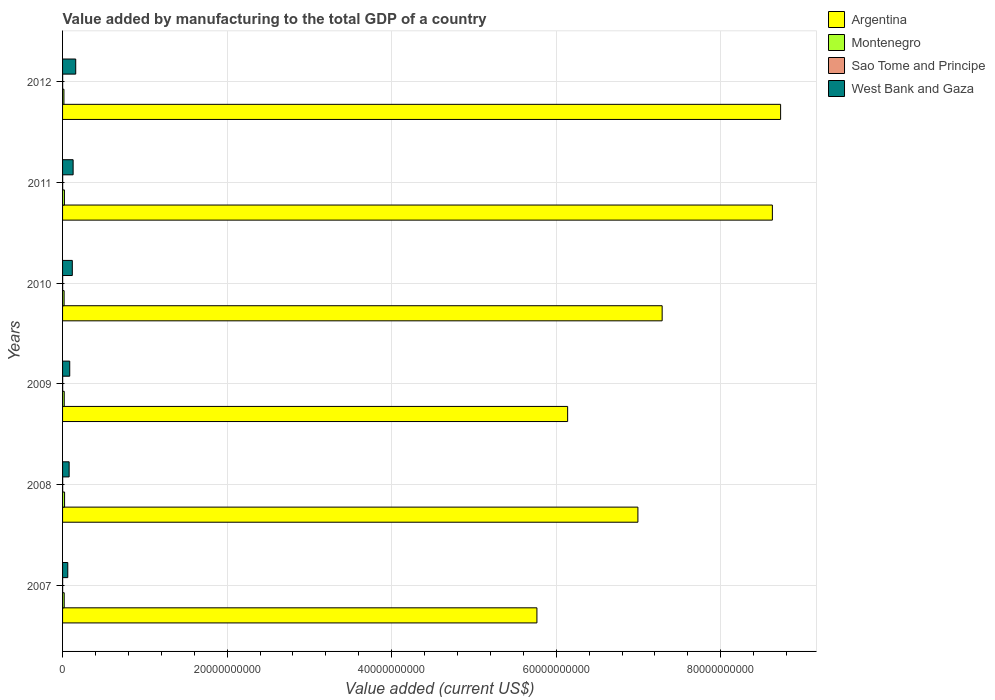Are the number of bars per tick equal to the number of legend labels?
Make the answer very short. Yes. How many bars are there on the 2nd tick from the top?
Provide a succinct answer. 4. How many bars are there on the 1st tick from the bottom?
Provide a short and direct response. 4. What is the label of the 3rd group of bars from the top?
Give a very brief answer. 2010. In how many cases, is the number of bars for a given year not equal to the number of legend labels?
Your response must be concise. 0. What is the value added by manufacturing to the total GDP in Montenegro in 2011?
Ensure brevity in your answer.  2.26e+08. Across all years, what is the maximum value added by manufacturing to the total GDP in Sao Tome and Principe?
Ensure brevity in your answer.  1.17e+07. Across all years, what is the minimum value added by manufacturing to the total GDP in West Bank and Gaza?
Give a very brief answer. 6.35e+08. What is the total value added by manufacturing to the total GDP in Sao Tome and Principe in the graph?
Ensure brevity in your answer.  6.28e+07. What is the difference between the value added by manufacturing to the total GDP in Sao Tome and Principe in 2008 and that in 2011?
Your response must be concise. 1.11e+04. What is the difference between the value added by manufacturing to the total GDP in Sao Tome and Principe in 2007 and the value added by manufacturing to the total GDP in Montenegro in 2012?
Provide a short and direct response. -1.60e+08. What is the average value added by manufacturing to the total GDP in Sao Tome and Principe per year?
Make the answer very short. 1.05e+07. In the year 2011, what is the difference between the value added by manufacturing to the total GDP in Argentina and value added by manufacturing to the total GDP in West Bank and Gaza?
Make the answer very short. 8.50e+1. What is the ratio of the value added by manufacturing to the total GDP in Argentina in 2007 to that in 2012?
Provide a succinct answer. 0.66. Is the value added by manufacturing to the total GDP in West Bank and Gaza in 2009 less than that in 2011?
Provide a succinct answer. Yes. Is the difference between the value added by manufacturing to the total GDP in Argentina in 2007 and 2012 greater than the difference between the value added by manufacturing to the total GDP in West Bank and Gaza in 2007 and 2012?
Offer a terse response. No. What is the difference between the highest and the second highest value added by manufacturing to the total GDP in Argentina?
Ensure brevity in your answer.  1.00e+09. What is the difference between the highest and the lowest value added by manufacturing to the total GDP in Sao Tome and Principe?
Provide a succinct answer. 4.55e+06. Is the sum of the value added by manufacturing to the total GDP in Argentina in 2008 and 2010 greater than the maximum value added by manufacturing to the total GDP in West Bank and Gaza across all years?
Your answer should be compact. Yes. Is it the case that in every year, the sum of the value added by manufacturing to the total GDP in Montenegro and value added by manufacturing to the total GDP in West Bank and Gaza is greater than the sum of value added by manufacturing to the total GDP in Sao Tome and Principe and value added by manufacturing to the total GDP in Argentina?
Ensure brevity in your answer.  No. What does the 4th bar from the bottom in 2012 represents?
Ensure brevity in your answer.  West Bank and Gaza. Is it the case that in every year, the sum of the value added by manufacturing to the total GDP in Montenegro and value added by manufacturing to the total GDP in Sao Tome and Principe is greater than the value added by manufacturing to the total GDP in Argentina?
Make the answer very short. No. Are all the bars in the graph horizontal?
Your answer should be compact. Yes. How many years are there in the graph?
Provide a short and direct response. 6. What is the difference between two consecutive major ticks on the X-axis?
Your answer should be compact. 2.00e+1. Does the graph contain any zero values?
Give a very brief answer. No. Where does the legend appear in the graph?
Offer a terse response. Top right. How many legend labels are there?
Your answer should be compact. 4. What is the title of the graph?
Your response must be concise. Value added by manufacturing to the total GDP of a country. What is the label or title of the X-axis?
Your answer should be very brief. Value added (current US$). What is the Value added (current US$) in Argentina in 2007?
Your answer should be compact. 5.77e+1. What is the Value added (current US$) in Montenegro in 2007?
Provide a succinct answer. 1.98e+08. What is the Value added (current US$) of Sao Tome and Principe in 2007?
Your answer should be very brief. 7.11e+06. What is the Value added (current US$) in West Bank and Gaza in 2007?
Your answer should be very brief. 6.35e+08. What is the Value added (current US$) in Argentina in 2008?
Ensure brevity in your answer.  6.99e+1. What is the Value added (current US$) of Montenegro in 2008?
Provide a succinct answer. 2.44e+08. What is the Value added (current US$) in Sao Tome and Principe in 2008?
Provide a short and direct response. 1.15e+07. What is the Value added (current US$) of West Bank and Gaza in 2008?
Your answer should be very brief. 7.98e+08. What is the Value added (current US$) in Argentina in 2009?
Your answer should be very brief. 6.14e+1. What is the Value added (current US$) of Montenegro in 2009?
Provide a succinct answer. 2.03e+08. What is the Value added (current US$) in Sao Tome and Principe in 2009?
Keep it short and to the point. 1.13e+07. What is the Value added (current US$) of West Bank and Gaza in 2009?
Make the answer very short. 8.71e+08. What is the Value added (current US$) in Argentina in 2010?
Provide a succinct answer. 7.29e+1. What is the Value added (current US$) of Montenegro in 2010?
Your answer should be very brief. 1.88e+08. What is the Value added (current US$) in Sao Tome and Principe in 2010?
Your response must be concise. 9.89e+06. What is the Value added (current US$) of West Bank and Gaza in 2010?
Provide a short and direct response. 1.18e+09. What is the Value added (current US$) in Argentina in 2011?
Offer a terse response. 8.63e+1. What is the Value added (current US$) of Montenegro in 2011?
Ensure brevity in your answer.  2.26e+08. What is the Value added (current US$) in Sao Tome and Principe in 2011?
Offer a very short reply. 1.14e+07. What is the Value added (current US$) in West Bank and Gaza in 2011?
Keep it short and to the point. 1.28e+09. What is the Value added (current US$) of Argentina in 2012?
Give a very brief answer. 8.73e+1. What is the Value added (current US$) of Montenegro in 2012?
Ensure brevity in your answer.  1.67e+08. What is the Value added (current US$) in Sao Tome and Principe in 2012?
Provide a succinct answer. 1.17e+07. What is the Value added (current US$) in West Bank and Gaza in 2012?
Keep it short and to the point. 1.60e+09. Across all years, what is the maximum Value added (current US$) of Argentina?
Provide a succinct answer. 8.73e+1. Across all years, what is the maximum Value added (current US$) in Montenegro?
Give a very brief answer. 2.44e+08. Across all years, what is the maximum Value added (current US$) in Sao Tome and Principe?
Make the answer very short. 1.17e+07. Across all years, what is the maximum Value added (current US$) in West Bank and Gaza?
Keep it short and to the point. 1.60e+09. Across all years, what is the minimum Value added (current US$) in Argentina?
Make the answer very short. 5.77e+1. Across all years, what is the minimum Value added (current US$) of Montenegro?
Your answer should be very brief. 1.67e+08. Across all years, what is the minimum Value added (current US$) in Sao Tome and Principe?
Your answer should be very brief. 7.11e+06. Across all years, what is the minimum Value added (current US$) of West Bank and Gaza?
Ensure brevity in your answer.  6.35e+08. What is the total Value added (current US$) in Argentina in the graph?
Offer a very short reply. 4.35e+11. What is the total Value added (current US$) of Montenegro in the graph?
Provide a short and direct response. 1.23e+09. What is the total Value added (current US$) of Sao Tome and Principe in the graph?
Your answer should be very brief. 6.28e+07. What is the total Value added (current US$) of West Bank and Gaza in the graph?
Provide a short and direct response. 6.37e+09. What is the difference between the Value added (current US$) in Argentina in 2007 and that in 2008?
Keep it short and to the point. -1.23e+1. What is the difference between the Value added (current US$) in Montenegro in 2007 and that in 2008?
Make the answer very short. -4.55e+07. What is the difference between the Value added (current US$) in Sao Tome and Principe in 2007 and that in 2008?
Give a very brief answer. -4.35e+06. What is the difference between the Value added (current US$) of West Bank and Gaza in 2007 and that in 2008?
Ensure brevity in your answer.  -1.64e+08. What is the difference between the Value added (current US$) in Argentina in 2007 and that in 2009?
Offer a terse response. -3.73e+09. What is the difference between the Value added (current US$) of Montenegro in 2007 and that in 2009?
Provide a short and direct response. -4.18e+06. What is the difference between the Value added (current US$) in Sao Tome and Principe in 2007 and that in 2009?
Keep it short and to the point. -4.17e+06. What is the difference between the Value added (current US$) of West Bank and Gaza in 2007 and that in 2009?
Give a very brief answer. -2.37e+08. What is the difference between the Value added (current US$) of Argentina in 2007 and that in 2010?
Your response must be concise. -1.52e+1. What is the difference between the Value added (current US$) of Montenegro in 2007 and that in 2010?
Your answer should be very brief. 9.92e+06. What is the difference between the Value added (current US$) in Sao Tome and Principe in 2007 and that in 2010?
Provide a short and direct response. -2.78e+06. What is the difference between the Value added (current US$) of West Bank and Gaza in 2007 and that in 2010?
Your response must be concise. -5.49e+08. What is the difference between the Value added (current US$) of Argentina in 2007 and that in 2011?
Ensure brevity in your answer.  -2.86e+1. What is the difference between the Value added (current US$) of Montenegro in 2007 and that in 2011?
Provide a short and direct response. -2.73e+07. What is the difference between the Value added (current US$) in Sao Tome and Principe in 2007 and that in 2011?
Offer a terse response. -4.34e+06. What is the difference between the Value added (current US$) in West Bank and Gaza in 2007 and that in 2011?
Ensure brevity in your answer.  -6.48e+08. What is the difference between the Value added (current US$) in Argentina in 2007 and that in 2012?
Your response must be concise. -2.96e+1. What is the difference between the Value added (current US$) of Montenegro in 2007 and that in 2012?
Make the answer very short. 3.17e+07. What is the difference between the Value added (current US$) in Sao Tome and Principe in 2007 and that in 2012?
Offer a very short reply. -4.55e+06. What is the difference between the Value added (current US$) of West Bank and Gaza in 2007 and that in 2012?
Keep it short and to the point. -9.63e+08. What is the difference between the Value added (current US$) of Argentina in 2008 and that in 2009?
Keep it short and to the point. 8.54e+09. What is the difference between the Value added (current US$) in Montenegro in 2008 and that in 2009?
Provide a succinct answer. 4.13e+07. What is the difference between the Value added (current US$) of Sao Tome and Principe in 2008 and that in 2009?
Ensure brevity in your answer.  1.76e+05. What is the difference between the Value added (current US$) in West Bank and Gaza in 2008 and that in 2009?
Make the answer very short. -7.30e+07. What is the difference between the Value added (current US$) in Argentina in 2008 and that in 2010?
Offer a terse response. -2.95e+09. What is the difference between the Value added (current US$) in Montenegro in 2008 and that in 2010?
Offer a terse response. 5.54e+07. What is the difference between the Value added (current US$) of Sao Tome and Principe in 2008 and that in 2010?
Your answer should be compact. 1.56e+06. What is the difference between the Value added (current US$) in West Bank and Gaza in 2008 and that in 2010?
Your response must be concise. -3.86e+08. What is the difference between the Value added (current US$) in Argentina in 2008 and that in 2011?
Offer a terse response. -1.63e+1. What is the difference between the Value added (current US$) of Montenegro in 2008 and that in 2011?
Provide a short and direct response. 1.82e+07. What is the difference between the Value added (current US$) in Sao Tome and Principe in 2008 and that in 2011?
Offer a very short reply. 1.11e+04. What is the difference between the Value added (current US$) in West Bank and Gaza in 2008 and that in 2011?
Provide a succinct answer. -4.84e+08. What is the difference between the Value added (current US$) of Argentina in 2008 and that in 2012?
Keep it short and to the point. -1.73e+1. What is the difference between the Value added (current US$) in Montenegro in 2008 and that in 2012?
Provide a succinct answer. 7.72e+07. What is the difference between the Value added (current US$) of Sao Tome and Principe in 2008 and that in 2012?
Make the answer very short. -2.03e+05. What is the difference between the Value added (current US$) in West Bank and Gaza in 2008 and that in 2012?
Provide a short and direct response. -8.00e+08. What is the difference between the Value added (current US$) in Argentina in 2009 and that in 2010?
Offer a very short reply. -1.15e+1. What is the difference between the Value added (current US$) in Montenegro in 2009 and that in 2010?
Your answer should be compact. 1.41e+07. What is the difference between the Value added (current US$) of Sao Tome and Principe in 2009 and that in 2010?
Offer a very short reply. 1.39e+06. What is the difference between the Value added (current US$) in West Bank and Gaza in 2009 and that in 2010?
Your response must be concise. -3.13e+08. What is the difference between the Value added (current US$) of Argentina in 2009 and that in 2011?
Provide a succinct answer. -2.49e+1. What is the difference between the Value added (current US$) of Montenegro in 2009 and that in 2011?
Offer a very short reply. -2.31e+07. What is the difference between the Value added (current US$) in Sao Tome and Principe in 2009 and that in 2011?
Your response must be concise. -1.65e+05. What is the difference between the Value added (current US$) in West Bank and Gaza in 2009 and that in 2011?
Make the answer very short. -4.12e+08. What is the difference between the Value added (current US$) in Argentina in 2009 and that in 2012?
Provide a succinct answer. -2.59e+1. What is the difference between the Value added (current US$) in Montenegro in 2009 and that in 2012?
Make the answer very short. 3.59e+07. What is the difference between the Value added (current US$) of Sao Tome and Principe in 2009 and that in 2012?
Your answer should be very brief. -3.79e+05. What is the difference between the Value added (current US$) in West Bank and Gaza in 2009 and that in 2012?
Your answer should be compact. -7.27e+08. What is the difference between the Value added (current US$) of Argentina in 2010 and that in 2011?
Your answer should be very brief. -1.34e+1. What is the difference between the Value added (current US$) in Montenegro in 2010 and that in 2011?
Give a very brief answer. -3.72e+07. What is the difference between the Value added (current US$) in Sao Tome and Principe in 2010 and that in 2011?
Provide a succinct answer. -1.55e+06. What is the difference between the Value added (current US$) in West Bank and Gaza in 2010 and that in 2011?
Ensure brevity in your answer.  -9.89e+07. What is the difference between the Value added (current US$) of Argentina in 2010 and that in 2012?
Your response must be concise. -1.44e+1. What is the difference between the Value added (current US$) in Montenegro in 2010 and that in 2012?
Offer a terse response. 2.18e+07. What is the difference between the Value added (current US$) in Sao Tome and Principe in 2010 and that in 2012?
Ensure brevity in your answer.  -1.77e+06. What is the difference between the Value added (current US$) in West Bank and Gaza in 2010 and that in 2012?
Ensure brevity in your answer.  -4.14e+08. What is the difference between the Value added (current US$) in Argentina in 2011 and that in 2012?
Your answer should be compact. -1.00e+09. What is the difference between the Value added (current US$) of Montenegro in 2011 and that in 2012?
Your answer should be compact. 5.90e+07. What is the difference between the Value added (current US$) of Sao Tome and Principe in 2011 and that in 2012?
Keep it short and to the point. -2.14e+05. What is the difference between the Value added (current US$) of West Bank and Gaza in 2011 and that in 2012?
Ensure brevity in your answer.  -3.15e+08. What is the difference between the Value added (current US$) in Argentina in 2007 and the Value added (current US$) in Montenegro in 2008?
Provide a short and direct response. 5.74e+1. What is the difference between the Value added (current US$) in Argentina in 2007 and the Value added (current US$) in Sao Tome and Principe in 2008?
Provide a short and direct response. 5.76e+1. What is the difference between the Value added (current US$) of Argentina in 2007 and the Value added (current US$) of West Bank and Gaza in 2008?
Your answer should be compact. 5.69e+1. What is the difference between the Value added (current US$) of Montenegro in 2007 and the Value added (current US$) of Sao Tome and Principe in 2008?
Offer a terse response. 1.87e+08. What is the difference between the Value added (current US$) of Montenegro in 2007 and the Value added (current US$) of West Bank and Gaza in 2008?
Ensure brevity in your answer.  -6.00e+08. What is the difference between the Value added (current US$) in Sao Tome and Principe in 2007 and the Value added (current US$) in West Bank and Gaza in 2008?
Offer a terse response. -7.91e+08. What is the difference between the Value added (current US$) of Argentina in 2007 and the Value added (current US$) of Montenegro in 2009?
Keep it short and to the point. 5.75e+1. What is the difference between the Value added (current US$) of Argentina in 2007 and the Value added (current US$) of Sao Tome and Principe in 2009?
Give a very brief answer. 5.76e+1. What is the difference between the Value added (current US$) in Argentina in 2007 and the Value added (current US$) in West Bank and Gaza in 2009?
Make the answer very short. 5.68e+1. What is the difference between the Value added (current US$) in Montenegro in 2007 and the Value added (current US$) in Sao Tome and Principe in 2009?
Ensure brevity in your answer.  1.87e+08. What is the difference between the Value added (current US$) of Montenegro in 2007 and the Value added (current US$) of West Bank and Gaza in 2009?
Keep it short and to the point. -6.73e+08. What is the difference between the Value added (current US$) of Sao Tome and Principe in 2007 and the Value added (current US$) of West Bank and Gaza in 2009?
Offer a terse response. -8.64e+08. What is the difference between the Value added (current US$) of Argentina in 2007 and the Value added (current US$) of Montenegro in 2010?
Provide a succinct answer. 5.75e+1. What is the difference between the Value added (current US$) of Argentina in 2007 and the Value added (current US$) of Sao Tome and Principe in 2010?
Keep it short and to the point. 5.76e+1. What is the difference between the Value added (current US$) of Argentina in 2007 and the Value added (current US$) of West Bank and Gaza in 2010?
Ensure brevity in your answer.  5.65e+1. What is the difference between the Value added (current US$) in Montenegro in 2007 and the Value added (current US$) in Sao Tome and Principe in 2010?
Your answer should be very brief. 1.88e+08. What is the difference between the Value added (current US$) in Montenegro in 2007 and the Value added (current US$) in West Bank and Gaza in 2010?
Your answer should be very brief. -9.86e+08. What is the difference between the Value added (current US$) in Sao Tome and Principe in 2007 and the Value added (current US$) in West Bank and Gaza in 2010?
Your response must be concise. -1.18e+09. What is the difference between the Value added (current US$) of Argentina in 2007 and the Value added (current US$) of Montenegro in 2011?
Your answer should be compact. 5.74e+1. What is the difference between the Value added (current US$) of Argentina in 2007 and the Value added (current US$) of Sao Tome and Principe in 2011?
Your response must be concise. 5.76e+1. What is the difference between the Value added (current US$) of Argentina in 2007 and the Value added (current US$) of West Bank and Gaza in 2011?
Ensure brevity in your answer.  5.64e+1. What is the difference between the Value added (current US$) in Montenegro in 2007 and the Value added (current US$) in Sao Tome and Principe in 2011?
Your answer should be very brief. 1.87e+08. What is the difference between the Value added (current US$) in Montenegro in 2007 and the Value added (current US$) in West Bank and Gaza in 2011?
Your answer should be very brief. -1.08e+09. What is the difference between the Value added (current US$) in Sao Tome and Principe in 2007 and the Value added (current US$) in West Bank and Gaza in 2011?
Keep it short and to the point. -1.28e+09. What is the difference between the Value added (current US$) in Argentina in 2007 and the Value added (current US$) in Montenegro in 2012?
Provide a succinct answer. 5.75e+1. What is the difference between the Value added (current US$) in Argentina in 2007 and the Value added (current US$) in Sao Tome and Principe in 2012?
Ensure brevity in your answer.  5.76e+1. What is the difference between the Value added (current US$) in Argentina in 2007 and the Value added (current US$) in West Bank and Gaza in 2012?
Provide a succinct answer. 5.61e+1. What is the difference between the Value added (current US$) of Montenegro in 2007 and the Value added (current US$) of Sao Tome and Principe in 2012?
Your response must be concise. 1.87e+08. What is the difference between the Value added (current US$) of Montenegro in 2007 and the Value added (current US$) of West Bank and Gaza in 2012?
Your response must be concise. -1.40e+09. What is the difference between the Value added (current US$) in Sao Tome and Principe in 2007 and the Value added (current US$) in West Bank and Gaza in 2012?
Make the answer very short. -1.59e+09. What is the difference between the Value added (current US$) of Argentina in 2008 and the Value added (current US$) of Montenegro in 2009?
Ensure brevity in your answer.  6.97e+1. What is the difference between the Value added (current US$) in Argentina in 2008 and the Value added (current US$) in Sao Tome and Principe in 2009?
Your answer should be compact. 6.99e+1. What is the difference between the Value added (current US$) in Argentina in 2008 and the Value added (current US$) in West Bank and Gaza in 2009?
Offer a very short reply. 6.91e+1. What is the difference between the Value added (current US$) in Montenegro in 2008 and the Value added (current US$) in Sao Tome and Principe in 2009?
Make the answer very short. 2.33e+08. What is the difference between the Value added (current US$) in Montenegro in 2008 and the Value added (current US$) in West Bank and Gaza in 2009?
Your answer should be compact. -6.28e+08. What is the difference between the Value added (current US$) in Sao Tome and Principe in 2008 and the Value added (current US$) in West Bank and Gaza in 2009?
Keep it short and to the point. -8.60e+08. What is the difference between the Value added (current US$) in Argentina in 2008 and the Value added (current US$) in Montenegro in 2010?
Give a very brief answer. 6.97e+1. What is the difference between the Value added (current US$) of Argentina in 2008 and the Value added (current US$) of Sao Tome and Principe in 2010?
Offer a terse response. 6.99e+1. What is the difference between the Value added (current US$) of Argentina in 2008 and the Value added (current US$) of West Bank and Gaza in 2010?
Ensure brevity in your answer.  6.87e+1. What is the difference between the Value added (current US$) in Montenegro in 2008 and the Value added (current US$) in Sao Tome and Principe in 2010?
Your answer should be very brief. 2.34e+08. What is the difference between the Value added (current US$) in Montenegro in 2008 and the Value added (current US$) in West Bank and Gaza in 2010?
Make the answer very short. -9.40e+08. What is the difference between the Value added (current US$) in Sao Tome and Principe in 2008 and the Value added (current US$) in West Bank and Gaza in 2010?
Ensure brevity in your answer.  -1.17e+09. What is the difference between the Value added (current US$) of Argentina in 2008 and the Value added (current US$) of Montenegro in 2011?
Your answer should be compact. 6.97e+1. What is the difference between the Value added (current US$) of Argentina in 2008 and the Value added (current US$) of Sao Tome and Principe in 2011?
Ensure brevity in your answer.  6.99e+1. What is the difference between the Value added (current US$) in Argentina in 2008 and the Value added (current US$) in West Bank and Gaza in 2011?
Your answer should be very brief. 6.86e+1. What is the difference between the Value added (current US$) of Montenegro in 2008 and the Value added (current US$) of Sao Tome and Principe in 2011?
Offer a terse response. 2.32e+08. What is the difference between the Value added (current US$) in Montenegro in 2008 and the Value added (current US$) in West Bank and Gaza in 2011?
Provide a succinct answer. -1.04e+09. What is the difference between the Value added (current US$) of Sao Tome and Principe in 2008 and the Value added (current US$) of West Bank and Gaza in 2011?
Provide a succinct answer. -1.27e+09. What is the difference between the Value added (current US$) in Argentina in 2008 and the Value added (current US$) in Montenegro in 2012?
Your response must be concise. 6.98e+1. What is the difference between the Value added (current US$) in Argentina in 2008 and the Value added (current US$) in Sao Tome and Principe in 2012?
Offer a very short reply. 6.99e+1. What is the difference between the Value added (current US$) in Argentina in 2008 and the Value added (current US$) in West Bank and Gaza in 2012?
Your answer should be compact. 6.83e+1. What is the difference between the Value added (current US$) of Montenegro in 2008 and the Value added (current US$) of Sao Tome and Principe in 2012?
Your answer should be very brief. 2.32e+08. What is the difference between the Value added (current US$) in Montenegro in 2008 and the Value added (current US$) in West Bank and Gaza in 2012?
Offer a terse response. -1.35e+09. What is the difference between the Value added (current US$) of Sao Tome and Principe in 2008 and the Value added (current US$) of West Bank and Gaza in 2012?
Your answer should be very brief. -1.59e+09. What is the difference between the Value added (current US$) in Argentina in 2009 and the Value added (current US$) in Montenegro in 2010?
Your answer should be compact. 6.12e+1. What is the difference between the Value added (current US$) in Argentina in 2009 and the Value added (current US$) in Sao Tome and Principe in 2010?
Keep it short and to the point. 6.14e+1. What is the difference between the Value added (current US$) in Argentina in 2009 and the Value added (current US$) in West Bank and Gaza in 2010?
Your answer should be very brief. 6.02e+1. What is the difference between the Value added (current US$) of Montenegro in 2009 and the Value added (current US$) of Sao Tome and Principe in 2010?
Keep it short and to the point. 1.93e+08. What is the difference between the Value added (current US$) of Montenegro in 2009 and the Value added (current US$) of West Bank and Gaza in 2010?
Your response must be concise. -9.81e+08. What is the difference between the Value added (current US$) of Sao Tome and Principe in 2009 and the Value added (current US$) of West Bank and Gaza in 2010?
Offer a terse response. -1.17e+09. What is the difference between the Value added (current US$) of Argentina in 2009 and the Value added (current US$) of Montenegro in 2011?
Provide a succinct answer. 6.12e+1. What is the difference between the Value added (current US$) of Argentina in 2009 and the Value added (current US$) of Sao Tome and Principe in 2011?
Provide a succinct answer. 6.14e+1. What is the difference between the Value added (current US$) in Argentina in 2009 and the Value added (current US$) in West Bank and Gaza in 2011?
Offer a terse response. 6.01e+1. What is the difference between the Value added (current US$) in Montenegro in 2009 and the Value added (current US$) in Sao Tome and Principe in 2011?
Ensure brevity in your answer.  1.91e+08. What is the difference between the Value added (current US$) of Montenegro in 2009 and the Value added (current US$) of West Bank and Gaza in 2011?
Offer a terse response. -1.08e+09. What is the difference between the Value added (current US$) in Sao Tome and Principe in 2009 and the Value added (current US$) in West Bank and Gaza in 2011?
Ensure brevity in your answer.  -1.27e+09. What is the difference between the Value added (current US$) in Argentina in 2009 and the Value added (current US$) in Montenegro in 2012?
Ensure brevity in your answer.  6.12e+1. What is the difference between the Value added (current US$) in Argentina in 2009 and the Value added (current US$) in Sao Tome and Principe in 2012?
Provide a succinct answer. 6.14e+1. What is the difference between the Value added (current US$) in Argentina in 2009 and the Value added (current US$) in West Bank and Gaza in 2012?
Keep it short and to the point. 5.98e+1. What is the difference between the Value added (current US$) of Montenegro in 2009 and the Value added (current US$) of Sao Tome and Principe in 2012?
Make the answer very short. 1.91e+08. What is the difference between the Value added (current US$) in Montenegro in 2009 and the Value added (current US$) in West Bank and Gaza in 2012?
Make the answer very short. -1.40e+09. What is the difference between the Value added (current US$) in Sao Tome and Principe in 2009 and the Value added (current US$) in West Bank and Gaza in 2012?
Provide a succinct answer. -1.59e+09. What is the difference between the Value added (current US$) of Argentina in 2010 and the Value added (current US$) of Montenegro in 2011?
Ensure brevity in your answer.  7.27e+1. What is the difference between the Value added (current US$) in Argentina in 2010 and the Value added (current US$) in Sao Tome and Principe in 2011?
Make the answer very short. 7.29e+1. What is the difference between the Value added (current US$) in Argentina in 2010 and the Value added (current US$) in West Bank and Gaza in 2011?
Your response must be concise. 7.16e+1. What is the difference between the Value added (current US$) of Montenegro in 2010 and the Value added (current US$) of Sao Tome and Principe in 2011?
Ensure brevity in your answer.  1.77e+08. What is the difference between the Value added (current US$) of Montenegro in 2010 and the Value added (current US$) of West Bank and Gaza in 2011?
Your response must be concise. -1.09e+09. What is the difference between the Value added (current US$) in Sao Tome and Principe in 2010 and the Value added (current US$) in West Bank and Gaza in 2011?
Give a very brief answer. -1.27e+09. What is the difference between the Value added (current US$) of Argentina in 2010 and the Value added (current US$) of Montenegro in 2012?
Offer a very short reply. 7.27e+1. What is the difference between the Value added (current US$) in Argentina in 2010 and the Value added (current US$) in Sao Tome and Principe in 2012?
Provide a succinct answer. 7.29e+1. What is the difference between the Value added (current US$) of Argentina in 2010 and the Value added (current US$) of West Bank and Gaza in 2012?
Make the answer very short. 7.13e+1. What is the difference between the Value added (current US$) in Montenegro in 2010 and the Value added (current US$) in Sao Tome and Principe in 2012?
Offer a very short reply. 1.77e+08. What is the difference between the Value added (current US$) in Montenegro in 2010 and the Value added (current US$) in West Bank and Gaza in 2012?
Your answer should be compact. -1.41e+09. What is the difference between the Value added (current US$) of Sao Tome and Principe in 2010 and the Value added (current US$) of West Bank and Gaza in 2012?
Keep it short and to the point. -1.59e+09. What is the difference between the Value added (current US$) in Argentina in 2011 and the Value added (current US$) in Montenegro in 2012?
Your answer should be very brief. 8.61e+1. What is the difference between the Value added (current US$) in Argentina in 2011 and the Value added (current US$) in Sao Tome and Principe in 2012?
Your response must be concise. 8.63e+1. What is the difference between the Value added (current US$) in Argentina in 2011 and the Value added (current US$) in West Bank and Gaza in 2012?
Your answer should be compact. 8.47e+1. What is the difference between the Value added (current US$) of Montenegro in 2011 and the Value added (current US$) of Sao Tome and Principe in 2012?
Offer a very short reply. 2.14e+08. What is the difference between the Value added (current US$) in Montenegro in 2011 and the Value added (current US$) in West Bank and Gaza in 2012?
Your answer should be compact. -1.37e+09. What is the difference between the Value added (current US$) of Sao Tome and Principe in 2011 and the Value added (current US$) of West Bank and Gaza in 2012?
Offer a terse response. -1.59e+09. What is the average Value added (current US$) in Argentina per year?
Keep it short and to the point. 7.26e+1. What is the average Value added (current US$) in Montenegro per year?
Offer a very short reply. 2.04e+08. What is the average Value added (current US$) of Sao Tome and Principe per year?
Provide a short and direct response. 1.05e+07. What is the average Value added (current US$) of West Bank and Gaza per year?
Give a very brief answer. 1.06e+09. In the year 2007, what is the difference between the Value added (current US$) of Argentina and Value added (current US$) of Montenegro?
Offer a terse response. 5.75e+1. In the year 2007, what is the difference between the Value added (current US$) in Argentina and Value added (current US$) in Sao Tome and Principe?
Give a very brief answer. 5.76e+1. In the year 2007, what is the difference between the Value added (current US$) of Argentina and Value added (current US$) of West Bank and Gaza?
Your answer should be very brief. 5.70e+1. In the year 2007, what is the difference between the Value added (current US$) of Montenegro and Value added (current US$) of Sao Tome and Principe?
Offer a terse response. 1.91e+08. In the year 2007, what is the difference between the Value added (current US$) in Montenegro and Value added (current US$) in West Bank and Gaza?
Provide a succinct answer. -4.36e+08. In the year 2007, what is the difference between the Value added (current US$) of Sao Tome and Principe and Value added (current US$) of West Bank and Gaza?
Offer a terse response. -6.28e+08. In the year 2008, what is the difference between the Value added (current US$) of Argentina and Value added (current US$) of Montenegro?
Your response must be concise. 6.97e+1. In the year 2008, what is the difference between the Value added (current US$) of Argentina and Value added (current US$) of Sao Tome and Principe?
Your answer should be very brief. 6.99e+1. In the year 2008, what is the difference between the Value added (current US$) of Argentina and Value added (current US$) of West Bank and Gaza?
Offer a very short reply. 6.91e+1. In the year 2008, what is the difference between the Value added (current US$) in Montenegro and Value added (current US$) in Sao Tome and Principe?
Your answer should be compact. 2.32e+08. In the year 2008, what is the difference between the Value added (current US$) in Montenegro and Value added (current US$) in West Bank and Gaza?
Your answer should be compact. -5.55e+08. In the year 2008, what is the difference between the Value added (current US$) in Sao Tome and Principe and Value added (current US$) in West Bank and Gaza?
Make the answer very short. -7.87e+08. In the year 2009, what is the difference between the Value added (current US$) in Argentina and Value added (current US$) in Montenegro?
Make the answer very short. 6.12e+1. In the year 2009, what is the difference between the Value added (current US$) of Argentina and Value added (current US$) of Sao Tome and Principe?
Your answer should be very brief. 6.14e+1. In the year 2009, what is the difference between the Value added (current US$) in Argentina and Value added (current US$) in West Bank and Gaza?
Your answer should be very brief. 6.05e+1. In the year 2009, what is the difference between the Value added (current US$) in Montenegro and Value added (current US$) in Sao Tome and Principe?
Offer a terse response. 1.91e+08. In the year 2009, what is the difference between the Value added (current US$) of Montenegro and Value added (current US$) of West Bank and Gaza?
Offer a very short reply. -6.69e+08. In the year 2009, what is the difference between the Value added (current US$) of Sao Tome and Principe and Value added (current US$) of West Bank and Gaza?
Give a very brief answer. -8.60e+08. In the year 2010, what is the difference between the Value added (current US$) in Argentina and Value added (current US$) in Montenegro?
Offer a very short reply. 7.27e+1. In the year 2010, what is the difference between the Value added (current US$) in Argentina and Value added (current US$) in Sao Tome and Principe?
Keep it short and to the point. 7.29e+1. In the year 2010, what is the difference between the Value added (current US$) in Argentina and Value added (current US$) in West Bank and Gaza?
Make the answer very short. 7.17e+1. In the year 2010, what is the difference between the Value added (current US$) of Montenegro and Value added (current US$) of Sao Tome and Principe?
Ensure brevity in your answer.  1.79e+08. In the year 2010, what is the difference between the Value added (current US$) in Montenegro and Value added (current US$) in West Bank and Gaza?
Provide a short and direct response. -9.96e+08. In the year 2010, what is the difference between the Value added (current US$) of Sao Tome and Principe and Value added (current US$) of West Bank and Gaza?
Make the answer very short. -1.17e+09. In the year 2011, what is the difference between the Value added (current US$) in Argentina and Value added (current US$) in Montenegro?
Your answer should be compact. 8.61e+1. In the year 2011, what is the difference between the Value added (current US$) in Argentina and Value added (current US$) in Sao Tome and Principe?
Give a very brief answer. 8.63e+1. In the year 2011, what is the difference between the Value added (current US$) of Argentina and Value added (current US$) of West Bank and Gaza?
Your answer should be compact. 8.50e+1. In the year 2011, what is the difference between the Value added (current US$) of Montenegro and Value added (current US$) of Sao Tome and Principe?
Ensure brevity in your answer.  2.14e+08. In the year 2011, what is the difference between the Value added (current US$) in Montenegro and Value added (current US$) in West Bank and Gaza?
Keep it short and to the point. -1.06e+09. In the year 2011, what is the difference between the Value added (current US$) in Sao Tome and Principe and Value added (current US$) in West Bank and Gaza?
Offer a terse response. -1.27e+09. In the year 2012, what is the difference between the Value added (current US$) of Argentina and Value added (current US$) of Montenegro?
Provide a succinct answer. 8.71e+1. In the year 2012, what is the difference between the Value added (current US$) in Argentina and Value added (current US$) in Sao Tome and Principe?
Ensure brevity in your answer.  8.73e+1. In the year 2012, what is the difference between the Value added (current US$) of Argentina and Value added (current US$) of West Bank and Gaza?
Give a very brief answer. 8.57e+1. In the year 2012, what is the difference between the Value added (current US$) of Montenegro and Value added (current US$) of Sao Tome and Principe?
Your answer should be compact. 1.55e+08. In the year 2012, what is the difference between the Value added (current US$) in Montenegro and Value added (current US$) in West Bank and Gaza?
Provide a succinct answer. -1.43e+09. In the year 2012, what is the difference between the Value added (current US$) in Sao Tome and Principe and Value added (current US$) in West Bank and Gaza?
Offer a terse response. -1.59e+09. What is the ratio of the Value added (current US$) of Argentina in 2007 to that in 2008?
Keep it short and to the point. 0.82. What is the ratio of the Value added (current US$) of Montenegro in 2007 to that in 2008?
Your answer should be very brief. 0.81. What is the ratio of the Value added (current US$) of Sao Tome and Principe in 2007 to that in 2008?
Your answer should be compact. 0.62. What is the ratio of the Value added (current US$) in West Bank and Gaza in 2007 to that in 2008?
Offer a terse response. 0.8. What is the ratio of the Value added (current US$) of Argentina in 2007 to that in 2009?
Provide a short and direct response. 0.94. What is the ratio of the Value added (current US$) in Montenegro in 2007 to that in 2009?
Offer a very short reply. 0.98. What is the ratio of the Value added (current US$) in Sao Tome and Principe in 2007 to that in 2009?
Your response must be concise. 0.63. What is the ratio of the Value added (current US$) in West Bank and Gaza in 2007 to that in 2009?
Provide a short and direct response. 0.73. What is the ratio of the Value added (current US$) of Argentina in 2007 to that in 2010?
Make the answer very short. 0.79. What is the ratio of the Value added (current US$) of Montenegro in 2007 to that in 2010?
Provide a succinct answer. 1.05. What is the ratio of the Value added (current US$) of Sao Tome and Principe in 2007 to that in 2010?
Keep it short and to the point. 0.72. What is the ratio of the Value added (current US$) in West Bank and Gaza in 2007 to that in 2010?
Keep it short and to the point. 0.54. What is the ratio of the Value added (current US$) of Argentina in 2007 to that in 2011?
Make the answer very short. 0.67. What is the ratio of the Value added (current US$) of Montenegro in 2007 to that in 2011?
Your answer should be compact. 0.88. What is the ratio of the Value added (current US$) of Sao Tome and Principe in 2007 to that in 2011?
Make the answer very short. 0.62. What is the ratio of the Value added (current US$) in West Bank and Gaza in 2007 to that in 2011?
Keep it short and to the point. 0.49. What is the ratio of the Value added (current US$) in Argentina in 2007 to that in 2012?
Give a very brief answer. 0.66. What is the ratio of the Value added (current US$) in Montenegro in 2007 to that in 2012?
Keep it short and to the point. 1.19. What is the ratio of the Value added (current US$) in Sao Tome and Principe in 2007 to that in 2012?
Provide a short and direct response. 0.61. What is the ratio of the Value added (current US$) of West Bank and Gaza in 2007 to that in 2012?
Keep it short and to the point. 0.4. What is the ratio of the Value added (current US$) in Argentina in 2008 to that in 2009?
Give a very brief answer. 1.14. What is the ratio of the Value added (current US$) in Montenegro in 2008 to that in 2009?
Make the answer very short. 1.2. What is the ratio of the Value added (current US$) in Sao Tome and Principe in 2008 to that in 2009?
Offer a terse response. 1.02. What is the ratio of the Value added (current US$) of West Bank and Gaza in 2008 to that in 2009?
Keep it short and to the point. 0.92. What is the ratio of the Value added (current US$) of Argentina in 2008 to that in 2010?
Ensure brevity in your answer.  0.96. What is the ratio of the Value added (current US$) of Montenegro in 2008 to that in 2010?
Provide a short and direct response. 1.29. What is the ratio of the Value added (current US$) of Sao Tome and Principe in 2008 to that in 2010?
Give a very brief answer. 1.16. What is the ratio of the Value added (current US$) of West Bank and Gaza in 2008 to that in 2010?
Ensure brevity in your answer.  0.67. What is the ratio of the Value added (current US$) of Argentina in 2008 to that in 2011?
Ensure brevity in your answer.  0.81. What is the ratio of the Value added (current US$) in Montenegro in 2008 to that in 2011?
Make the answer very short. 1.08. What is the ratio of the Value added (current US$) of West Bank and Gaza in 2008 to that in 2011?
Keep it short and to the point. 0.62. What is the ratio of the Value added (current US$) of Argentina in 2008 to that in 2012?
Provide a succinct answer. 0.8. What is the ratio of the Value added (current US$) of Montenegro in 2008 to that in 2012?
Offer a very short reply. 1.46. What is the ratio of the Value added (current US$) of Sao Tome and Principe in 2008 to that in 2012?
Your response must be concise. 0.98. What is the ratio of the Value added (current US$) in West Bank and Gaza in 2008 to that in 2012?
Provide a short and direct response. 0.5. What is the ratio of the Value added (current US$) of Argentina in 2009 to that in 2010?
Keep it short and to the point. 0.84. What is the ratio of the Value added (current US$) of Montenegro in 2009 to that in 2010?
Provide a short and direct response. 1.07. What is the ratio of the Value added (current US$) in Sao Tome and Principe in 2009 to that in 2010?
Offer a very short reply. 1.14. What is the ratio of the Value added (current US$) in West Bank and Gaza in 2009 to that in 2010?
Your response must be concise. 0.74. What is the ratio of the Value added (current US$) of Argentina in 2009 to that in 2011?
Provide a succinct answer. 0.71. What is the ratio of the Value added (current US$) of Montenegro in 2009 to that in 2011?
Ensure brevity in your answer.  0.9. What is the ratio of the Value added (current US$) in Sao Tome and Principe in 2009 to that in 2011?
Your answer should be very brief. 0.99. What is the ratio of the Value added (current US$) of West Bank and Gaza in 2009 to that in 2011?
Provide a short and direct response. 0.68. What is the ratio of the Value added (current US$) of Argentina in 2009 to that in 2012?
Give a very brief answer. 0.7. What is the ratio of the Value added (current US$) of Montenegro in 2009 to that in 2012?
Offer a very short reply. 1.22. What is the ratio of the Value added (current US$) of Sao Tome and Principe in 2009 to that in 2012?
Your answer should be compact. 0.97. What is the ratio of the Value added (current US$) in West Bank and Gaza in 2009 to that in 2012?
Ensure brevity in your answer.  0.55. What is the ratio of the Value added (current US$) of Argentina in 2010 to that in 2011?
Give a very brief answer. 0.84. What is the ratio of the Value added (current US$) in Montenegro in 2010 to that in 2011?
Offer a very short reply. 0.84. What is the ratio of the Value added (current US$) in Sao Tome and Principe in 2010 to that in 2011?
Your answer should be very brief. 0.86. What is the ratio of the Value added (current US$) in West Bank and Gaza in 2010 to that in 2011?
Keep it short and to the point. 0.92. What is the ratio of the Value added (current US$) of Argentina in 2010 to that in 2012?
Offer a terse response. 0.83. What is the ratio of the Value added (current US$) of Montenegro in 2010 to that in 2012?
Your answer should be compact. 1.13. What is the ratio of the Value added (current US$) in Sao Tome and Principe in 2010 to that in 2012?
Keep it short and to the point. 0.85. What is the ratio of the Value added (current US$) of West Bank and Gaza in 2010 to that in 2012?
Offer a very short reply. 0.74. What is the ratio of the Value added (current US$) of Montenegro in 2011 to that in 2012?
Offer a very short reply. 1.35. What is the ratio of the Value added (current US$) of Sao Tome and Principe in 2011 to that in 2012?
Provide a short and direct response. 0.98. What is the ratio of the Value added (current US$) of West Bank and Gaza in 2011 to that in 2012?
Your answer should be very brief. 0.8. What is the difference between the highest and the second highest Value added (current US$) of Argentina?
Give a very brief answer. 1.00e+09. What is the difference between the highest and the second highest Value added (current US$) in Montenegro?
Give a very brief answer. 1.82e+07. What is the difference between the highest and the second highest Value added (current US$) of Sao Tome and Principe?
Your answer should be compact. 2.03e+05. What is the difference between the highest and the second highest Value added (current US$) of West Bank and Gaza?
Your answer should be very brief. 3.15e+08. What is the difference between the highest and the lowest Value added (current US$) in Argentina?
Provide a succinct answer. 2.96e+1. What is the difference between the highest and the lowest Value added (current US$) of Montenegro?
Your answer should be compact. 7.72e+07. What is the difference between the highest and the lowest Value added (current US$) of Sao Tome and Principe?
Offer a terse response. 4.55e+06. What is the difference between the highest and the lowest Value added (current US$) in West Bank and Gaza?
Offer a very short reply. 9.63e+08. 